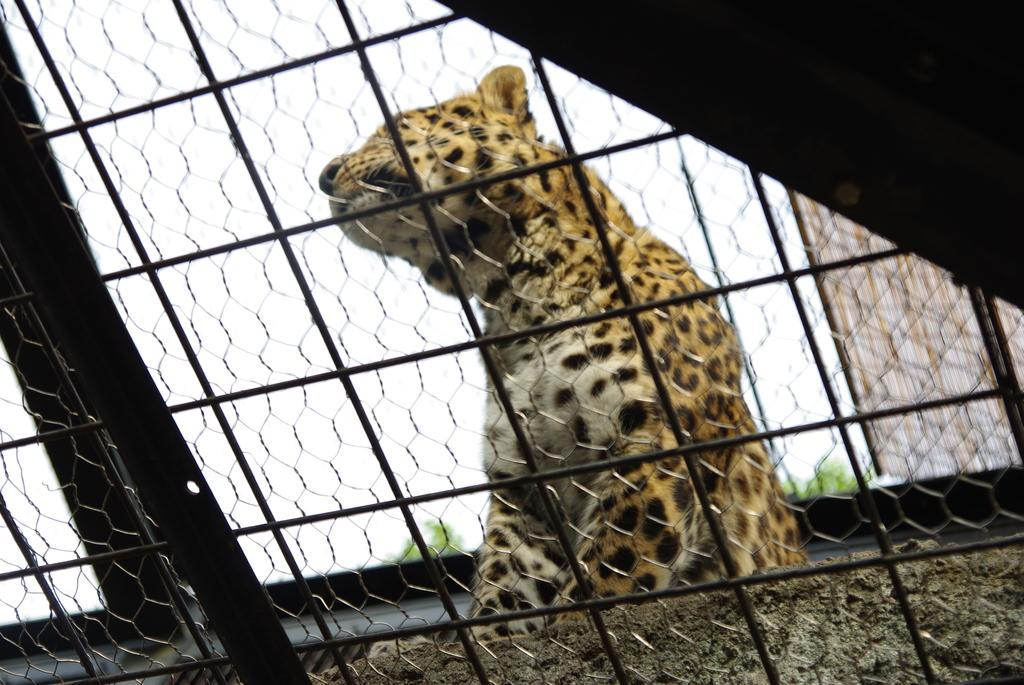What type of structure can be seen in the image? There is a fencing in the image. What animal is behind the fencing? There is a leopard behind the fencing in the image. What shape is the leopard's ear in the image? There is no information about the shape of the leopard's ear in the image, as the focus is on the fencing and the presence of the leopard. 